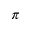<formula> <loc_0><loc_0><loc_500><loc_500>\pi</formula> 